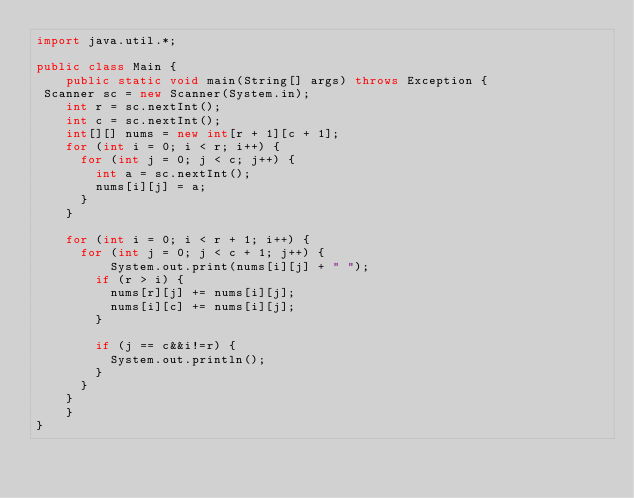Convert code to text. <code><loc_0><loc_0><loc_500><loc_500><_Java_>import java.util.*;

public class Main {
    public static void main(String[] args) throws Exception {
 Scanner sc = new Scanner(System.in);
		int r = sc.nextInt();
		int c = sc.nextInt();
		int[][] nums = new int[r + 1][c + 1];
		for (int i = 0; i < r; i++) {
			for (int j = 0; j < c; j++) {
				int a = sc.nextInt();
				nums[i][j] = a;
			}
		}

		for (int i = 0; i < r + 1; i++) {
			for (int j = 0; j < c + 1; j++) {
					System.out.print(nums[i][j] + " ");
				if (r > i) {
					nums[r][j] += nums[i][j];
					nums[i][c] += nums[i][j];
				}

				if (j == c&&i!=r) {
					System.out.println();
				}
			}
		}
    }
}

</code> 